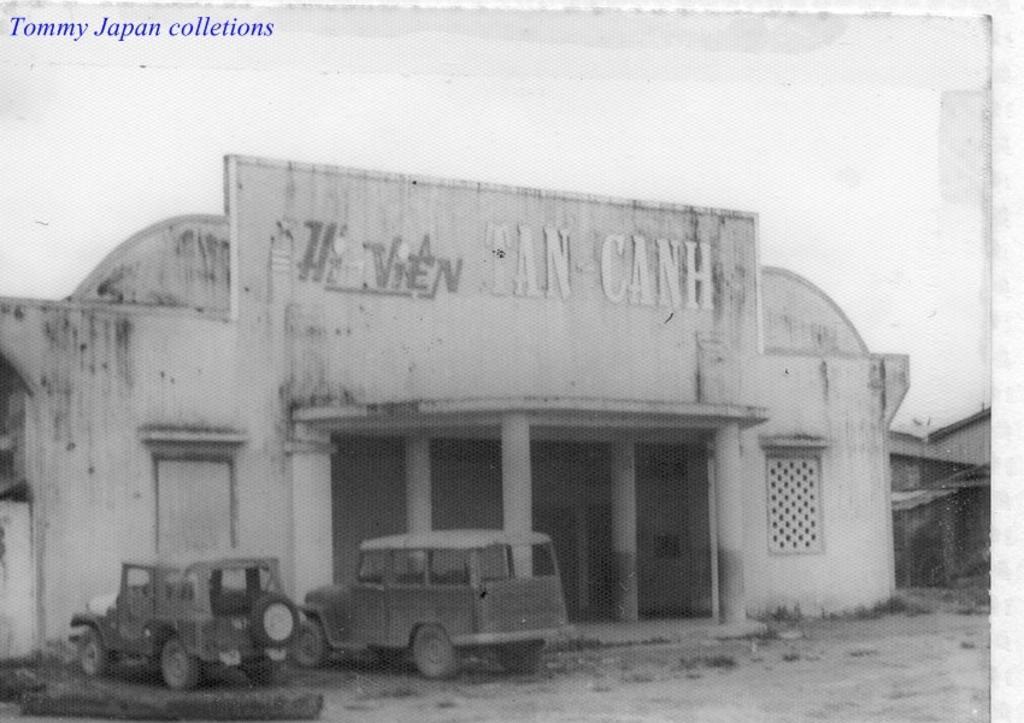Describe this image in one or two sentences. This is a black and white photography. In this image we can see vehicles on the ground, buildings, windows, texts written on the wall and sky. At the top we can see texts written on the image. 